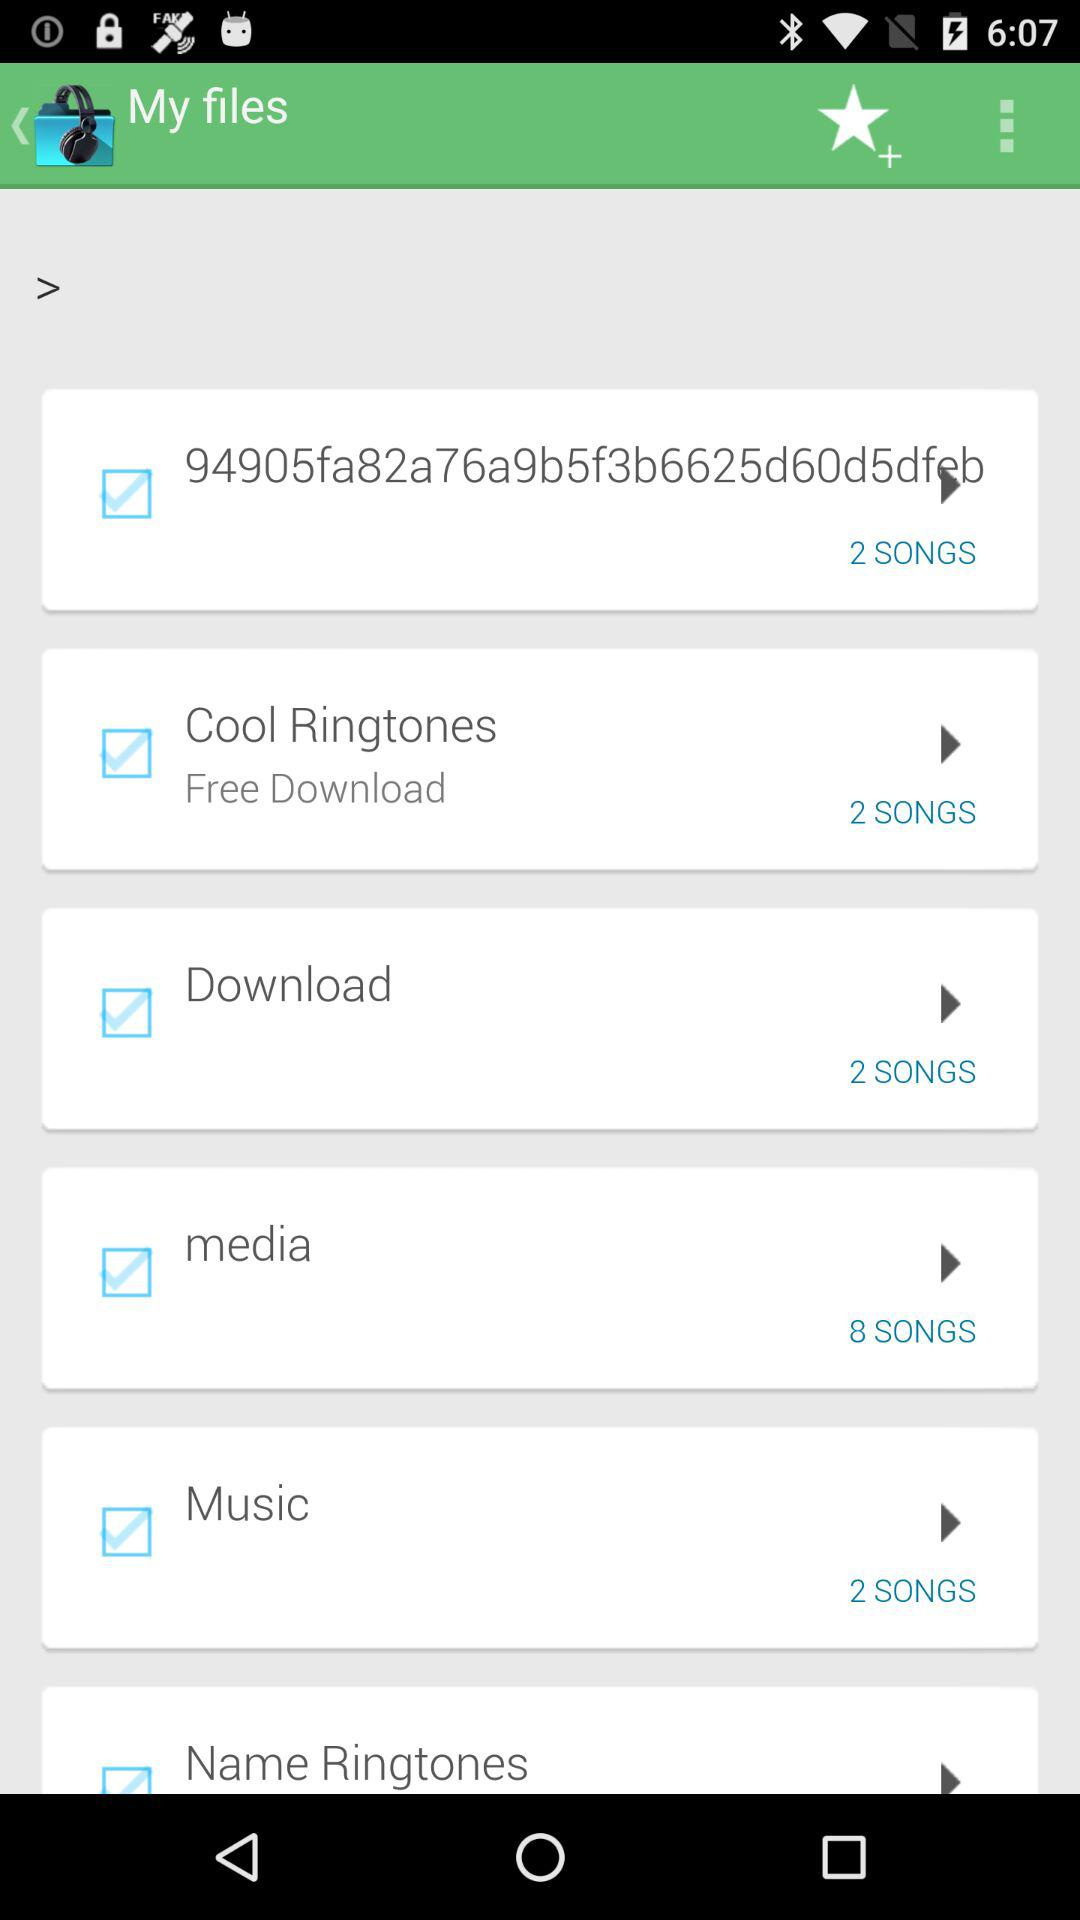What are the categories in "My files"? The categories in "My files" are "94905fa82a76a9b5f3b6625d60d5dfeb", "Cool Ringtones", "Download", "media", "Music" and "Name Ringtones". 